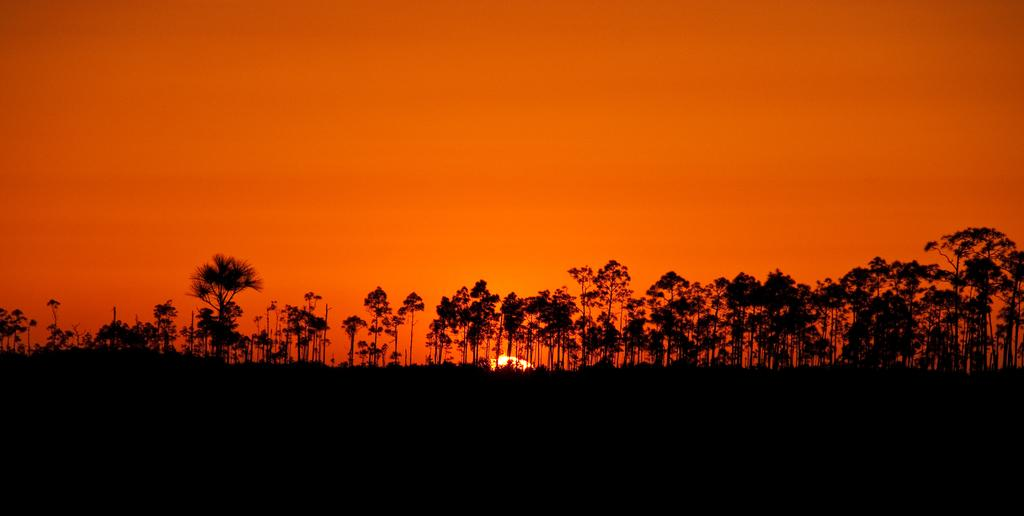What is the color or lighting condition at the bottom of the image? The bottom of the image is dark. What type of natural elements can be seen in the image? There are trees in the image. What celestial body is visible in the image? The sun is visible in the image. What part of the natural environment is visible in the image? The sky is visible in the image. What type of airplane is flying through the trees in the image? There is no airplane present in the image; it only features trees and the sky. Can you tell me how many fans are visible in the image? There are no fans present in the image. 